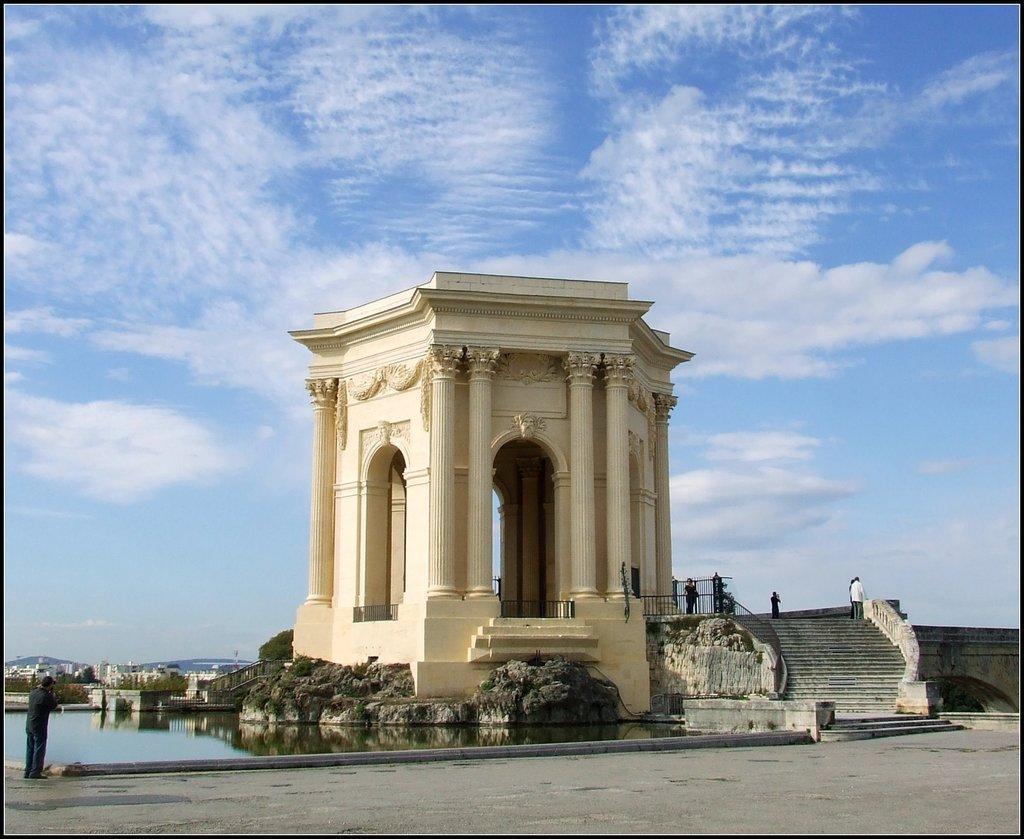In one or two sentences, can you explain what this image depicts? In this image, I can see an architecture on a rock. There are iron grilles, few people, stairway and I can see water. At the bottom of the image, I can see a pathway. On the left side of the image, there are buildings, trees and hills. In the background there is the sky. 